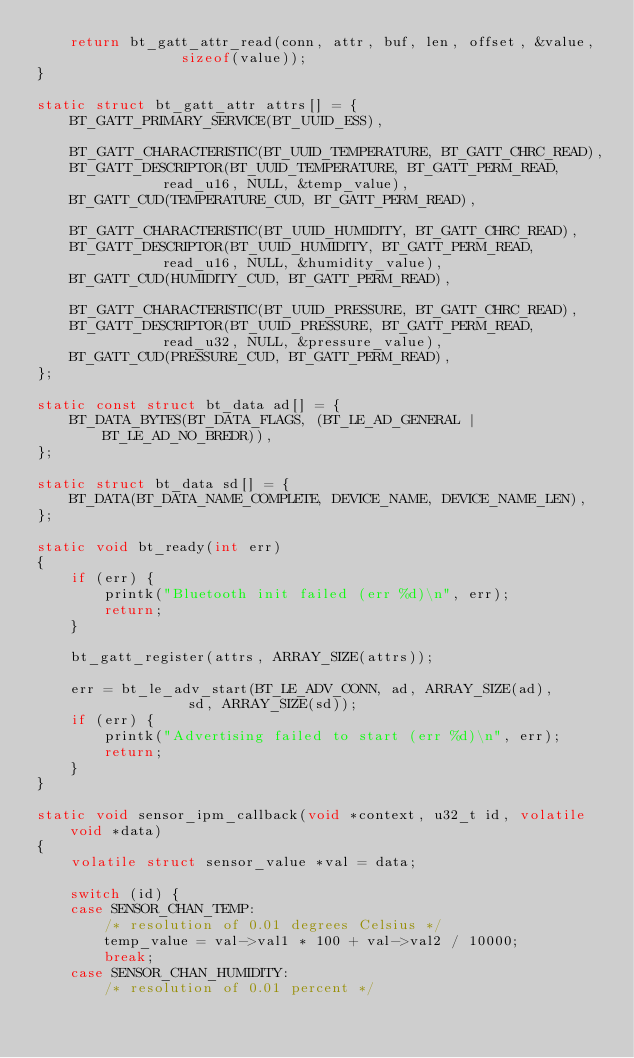<code> <loc_0><loc_0><loc_500><loc_500><_C_>	return bt_gatt_attr_read(conn, attr, buf, len, offset, &value,
				 sizeof(value));
}

static struct bt_gatt_attr attrs[] = {
	BT_GATT_PRIMARY_SERVICE(BT_UUID_ESS),

	BT_GATT_CHARACTERISTIC(BT_UUID_TEMPERATURE, BT_GATT_CHRC_READ),
	BT_GATT_DESCRIPTOR(BT_UUID_TEMPERATURE, BT_GATT_PERM_READ,
			   read_u16, NULL, &temp_value),
	BT_GATT_CUD(TEMPERATURE_CUD, BT_GATT_PERM_READ),

	BT_GATT_CHARACTERISTIC(BT_UUID_HUMIDITY, BT_GATT_CHRC_READ),
	BT_GATT_DESCRIPTOR(BT_UUID_HUMIDITY, BT_GATT_PERM_READ,
			   read_u16, NULL, &humidity_value),
	BT_GATT_CUD(HUMIDITY_CUD, BT_GATT_PERM_READ),

	BT_GATT_CHARACTERISTIC(BT_UUID_PRESSURE, BT_GATT_CHRC_READ),
	BT_GATT_DESCRIPTOR(BT_UUID_PRESSURE, BT_GATT_PERM_READ,
			   read_u32, NULL, &pressure_value),
	BT_GATT_CUD(PRESSURE_CUD, BT_GATT_PERM_READ),
};

static const struct bt_data ad[] = {
	BT_DATA_BYTES(BT_DATA_FLAGS, (BT_LE_AD_GENERAL | BT_LE_AD_NO_BREDR)),
};

static struct bt_data sd[] = {
	BT_DATA(BT_DATA_NAME_COMPLETE, DEVICE_NAME, DEVICE_NAME_LEN),
};

static void bt_ready(int err)
{
	if (err) {
		printk("Bluetooth init failed (err %d)\n", err);
		return;
	}

	bt_gatt_register(attrs, ARRAY_SIZE(attrs));

	err = bt_le_adv_start(BT_LE_ADV_CONN, ad, ARRAY_SIZE(ad),
			      sd, ARRAY_SIZE(sd));
	if (err) {
		printk("Advertising failed to start (err %d)\n", err);
		return;
	}
}

static void sensor_ipm_callback(void *context, u32_t id, volatile void *data)
{
	volatile struct sensor_value *val = data;

	switch (id) {
	case SENSOR_CHAN_TEMP:
		/* resolution of 0.01 degrees Celsius */
		temp_value = val->val1 * 100 + val->val2 / 10000;
		break;
	case SENSOR_CHAN_HUMIDITY:
		/* resolution of 0.01 percent */</code> 